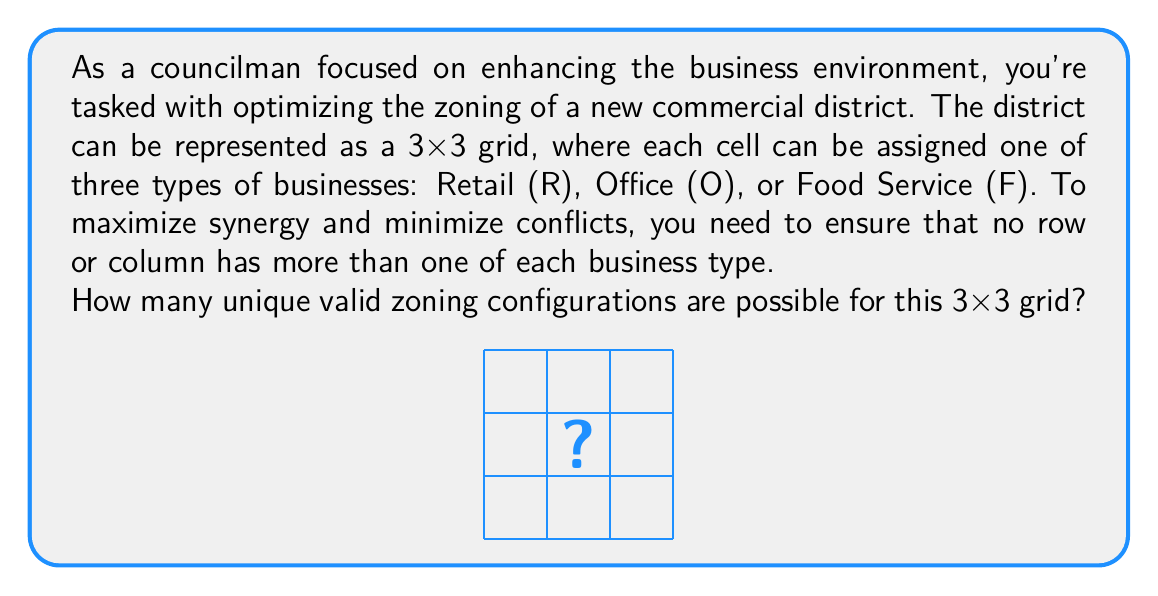Solve this math problem. To solve this problem, we can use concepts from abstract algebra, specifically group theory and permutations.

1) First, let's consider a single row or column. It must contain one of each business type (R, O, F). This is equivalent to the permutations of 3 elements, which is 3! = 6.

2) Now, let's think about the structure of the entire grid. If we fix the first row, the remaining two rows are determined because each column must also contain one of each business type.

3) This means that once we choose a permutation for the first row, the rest of the grid is uniquely determined. Therefore, the number of valid configurations is equal to the number of permutations of the first row.

4) We can represent this mathematically using the symmetric group $S_3$, which contains all permutations of 3 elements. The order of $S_3$ is 3! = 6.

5) To verify this, let's list out all possible configurations:

   ROF  RFO  ORF  OFR  FRO  FOR
   FRO  FOR  FRO  FOR  ORF  ORF
   OFR  OFR  ROF  RFO  RFO  ROF

6) Indeed, we can see that there are exactly 6 unique valid configurations.

This problem demonstrates how abstract algebra concepts like permutation groups can be applied to urban planning and zoning strategies, allowing for efficient enumeration and analysis of possible configurations.
Answer: 6 